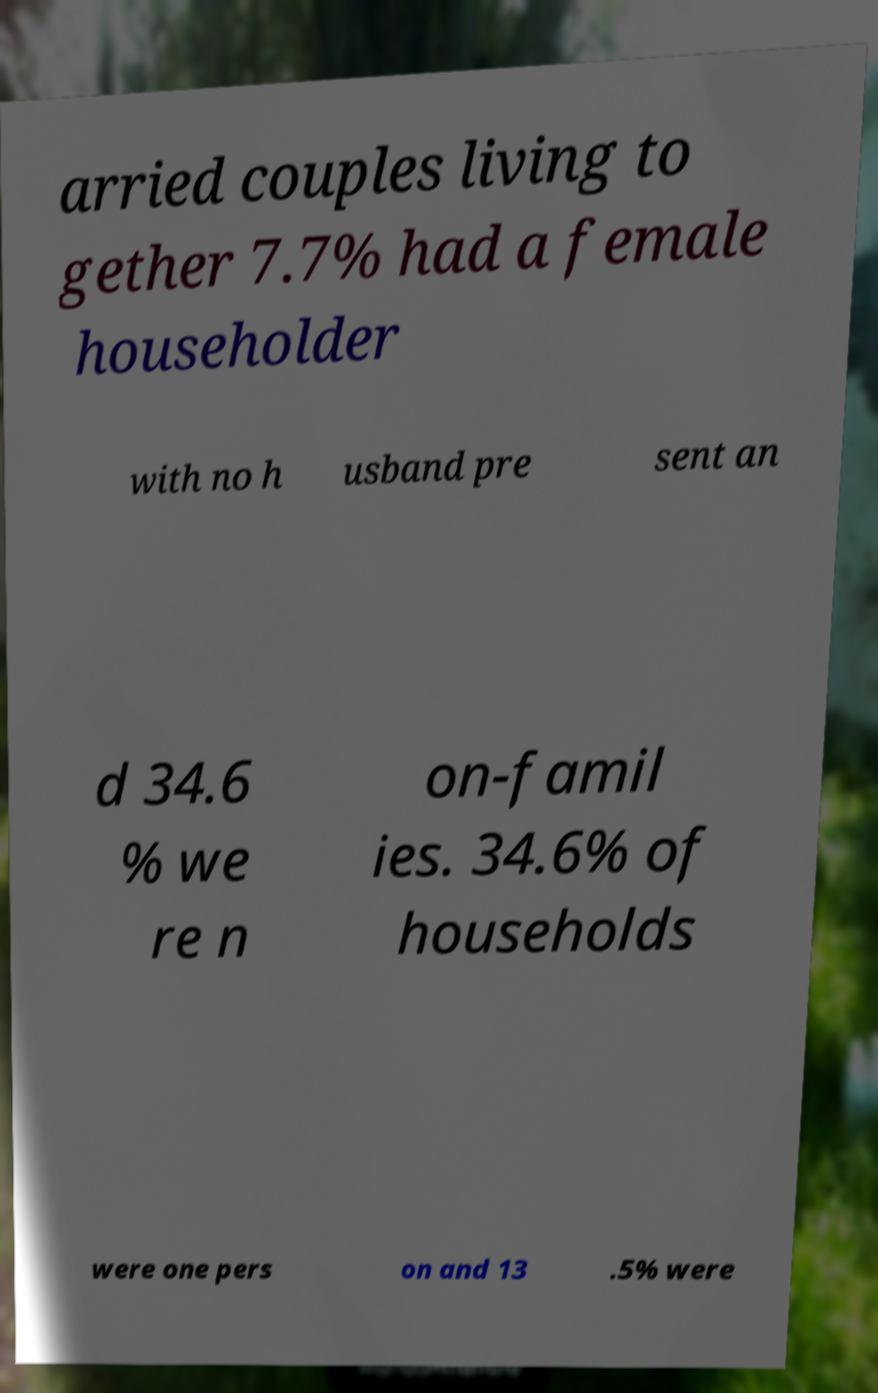Please identify and transcribe the text found in this image. arried couples living to gether 7.7% had a female householder with no h usband pre sent an d 34.6 % we re n on-famil ies. 34.6% of households were one pers on and 13 .5% were 